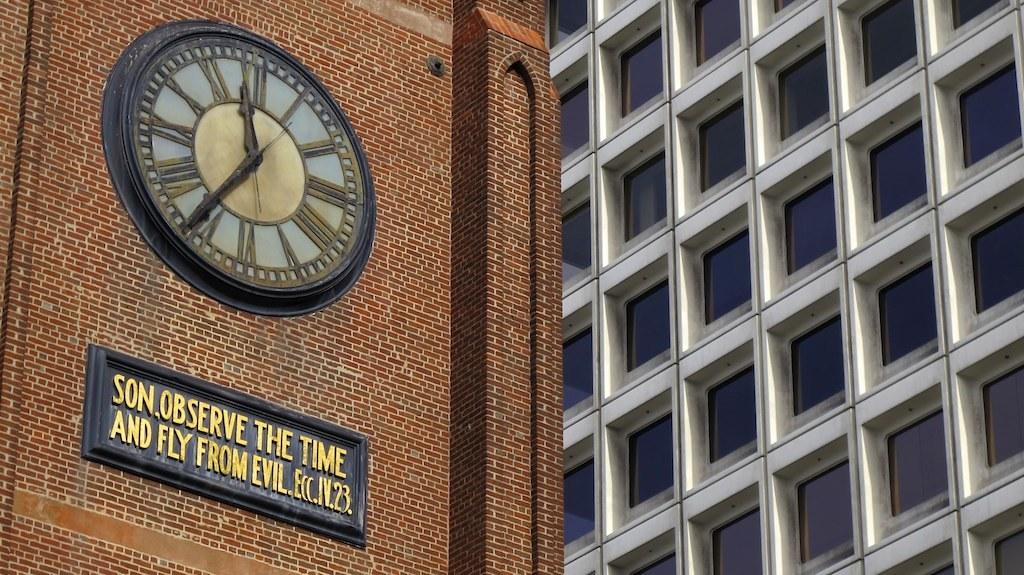Provide a one-sentence caption for the provided image. A plack beneath a clock reads "Son, observe the time and fly from evil". 